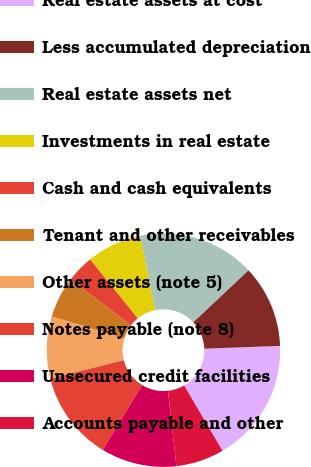Convert chart. <chart><loc_0><loc_0><loc_500><loc_500><pie_chart><fcel>Real estate assets at cost<fcel>Less accumulated depreciation<fcel>Real estate assets net<fcel>Investments in real estate<fcel>Cash and cash equivalents<fcel>Tenant and other receivables<fcel>Other assets (note 5)<fcel>Notes payable (note 8)<fcel>Unsecured credit facilities<fcel>Accounts payable and other<nl><fcel>17.14%<fcel>11.43%<fcel>16.19%<fcel>7.62%<fcel>3.81%<fcel>5.72%<fcel>8.57%<fcel>12.38%<fcel>10.48%<fcel>6.67%<nl></chart> 